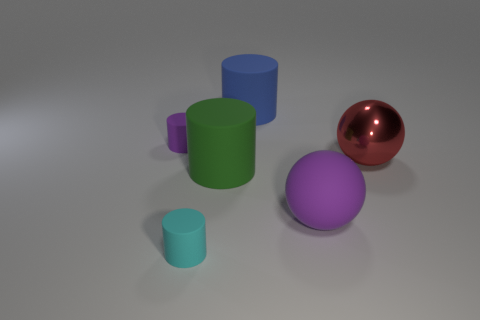What is the color of the other small object that is the same shape as the tiny purple thing?
Offer a terse response. Cyan. Do the ball that is to the left of the red object and the shiny thing have the same size?
Keep it short and to the point. Yes. Is the number of big red metal spheres that are in front of the cyan thing less than the number of small cylinders that are right of the big red sphere?
Offer a terse response. No. Is the metallic object the same color as the large rubber ball?
Your response must be concise. No. Are there fewer purple objects that are on the left side of the blue rubber cylinder than green rubber cylinders?
Ensure brevity in your answer.  No. What material is the tiny object that is the same color as the big rubber sphere?
Your response must be concise. Rubber. Do the large green cylinder and the small purple cylinder have the same material?
Provide a succinct answer. Yes. How many tiny red cylinders are the same material as the large purple ball?
Make the answer very short. 0. What is the color of the ball that is made of the same material as the green cylinder?
Offer a very short reply. Purple. What shape is the large metallic thing?
Provide a succinct answer. Sphere. 